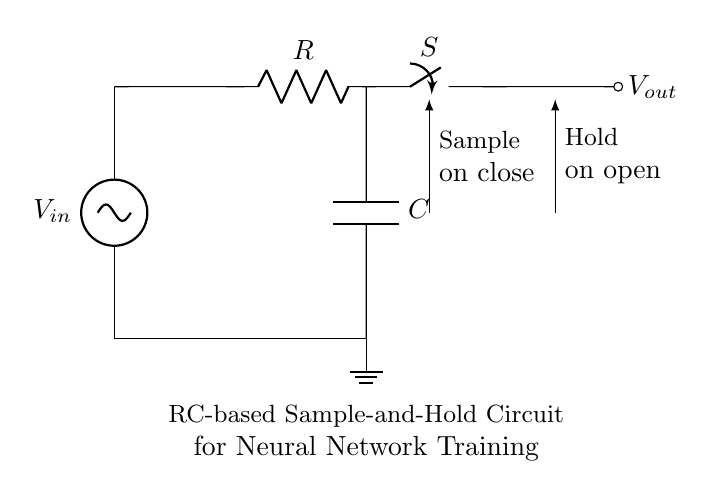What is the function of the switch in this circuit? The switch controls the sampling and holding process; it allows the capacitor to charge to the input voltage when closed and holds that voltage when opened.
Answer: Sample and hold What component is used to store charge in this circuit? The capacitor is the component responsible for storing charge in the circuit, allowing it to maintain a voltage level during the hold period.
Answer: Capacitor What does the resistor in the circuit do? The resistor limits the charging current into the capacitor, affecting the time constant of the circuit which determines how quickly the voltage across the capacitor can change.
Answer: Limits current What happens to the output voltage when the switch is opened? When the switch is opened, the output voltage remains constant, holding the last sampled voltage by the capacitor until the switch is closed again.
Answer: Remains constant How does the time constant affect the circuit? The time constant, defined by the product of the resistance and capacitance (RC), determines how quickly the capacitor charges or discharges, influencing the sample rate and accuracy of the output.
Answer: Affects charging rate What role does the input voltage play in this circuit? The input voltage is the voltage level that the capacitor charges to when the switch is closed, thereby determining the output voltage during the hold phase.
Answer: Sets output level 